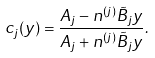<formula> <loc_0><loc_0><loc_500><loc_500>c _ { j } ( y ) = \frac { A _ { j } - n ^ { ( j ) } \tilde { B } _ { j } y } { A _ { j } + n ^ { ( j ) } \tilde { B } _ { j } y } .</formula> 